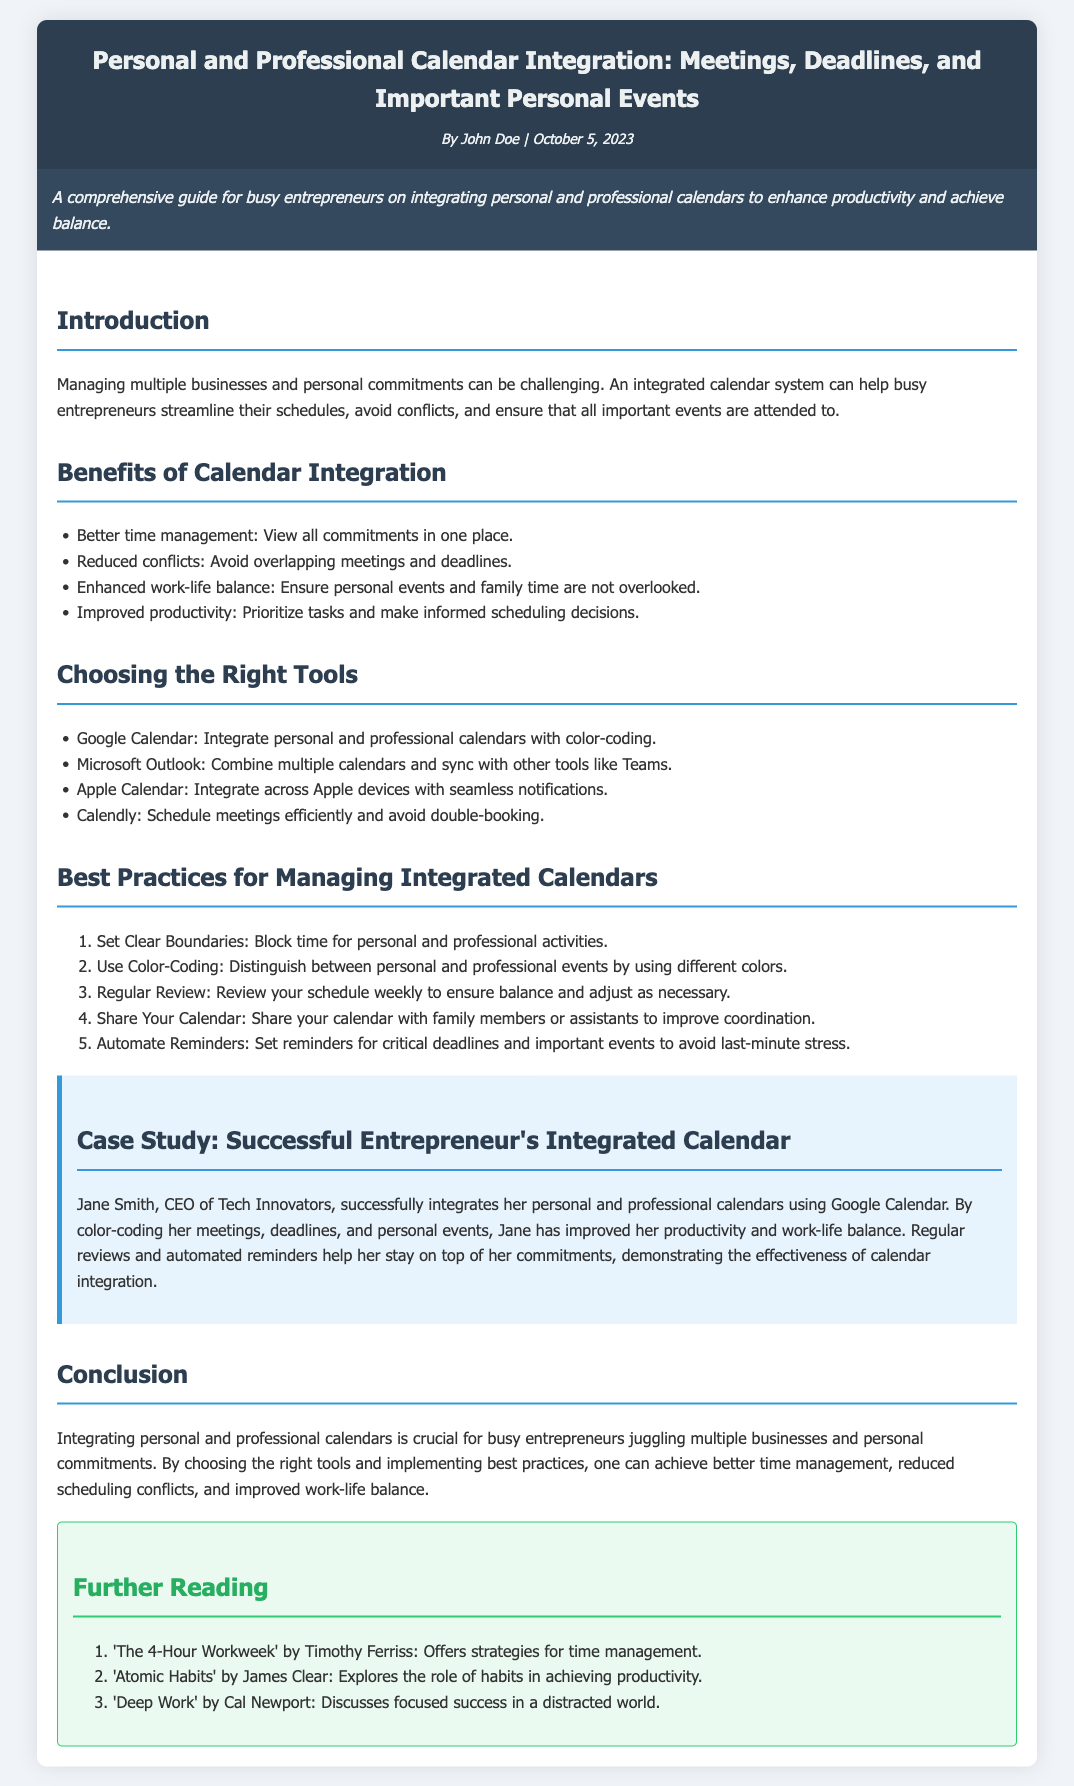What is the title of the datasheet? The title of the datasheet is clearly stated at the top of the document.
Answer: Personal and Professional Calendar Integration: Meetings, Deadlines, and Important Personal Events Who is the author of the datasheet? The author is mentioned in the header section of the document.
Answer: John Doe When was the datasheet published? The publication date is listed alongside the author's name in the header.
Answer: October 5, 2023 Name one of the tools recommended for calendar integration. Tools are listed under the section "Choosing the Right Tools" in the datasheet.
Answer: Google Calendar What is a benefit of calendar integration mentioned in the document? Benefits are outlined in the "Benefits of Calendar Integration" section.
Answer: Better time management How often should you review your schedule according to the best practices? The frequency of schedule review is specified in the section about best practices.
Answer: Weekly Who is the case study about? The case study section gives details about an individual's success with calendar integration.
Answer: Jane Smith What strategy does Jane use for her calendar? The case study section explains how Jane organizes her calendar.
Answer: Color-coding What is one of the books suggested for further reading? The "Further Reading" section lists recommended books.
Answer: The 4-Hour Workweek by Timothy Ferriss 